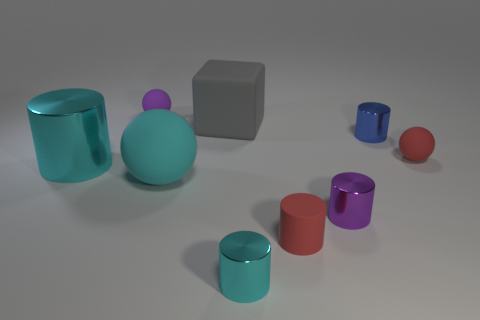There is a large shiny object that is the same color as the large ball; what is its shape?
Provide a succinct answer. Cylinder. Is there a tiny rubber thing of the same color as the rubber cylinder?
Give a very brief answer. Yes. What is the size of the rubber thing that is the same color as the tiny matte cylinder?
Your answer should be compact. Small. What shape is the rubber object that is behind the big cyan metal object and on the right side of the small cyan metal thing?
Make the answer very short. Sphere. Do the red matte cylinder and the blue thing have the same size?
Your answer should be compact. Yes. There is a rubber block; what number of purple rubber objects are in front of it?
Offer a very short reply. 0. Is the number of small purple cylinders behind the blue metal thing the same as the number of gray rubber things in front of the cyan matte sphere?
Make the answer very short. Yes. Is the shape of the tiny purple object behind the big cyan metallic cylinder the same as  the cyan rubber object?
Give a very brief answer. Yes. There is a purple ball; is it the same size as the rubber thing on the right side of the tiny blue cylinder?
Make the answer very short. Yes. What number of other objects are the same color as the large rubber cube?
Offer a very short reply. 0. 